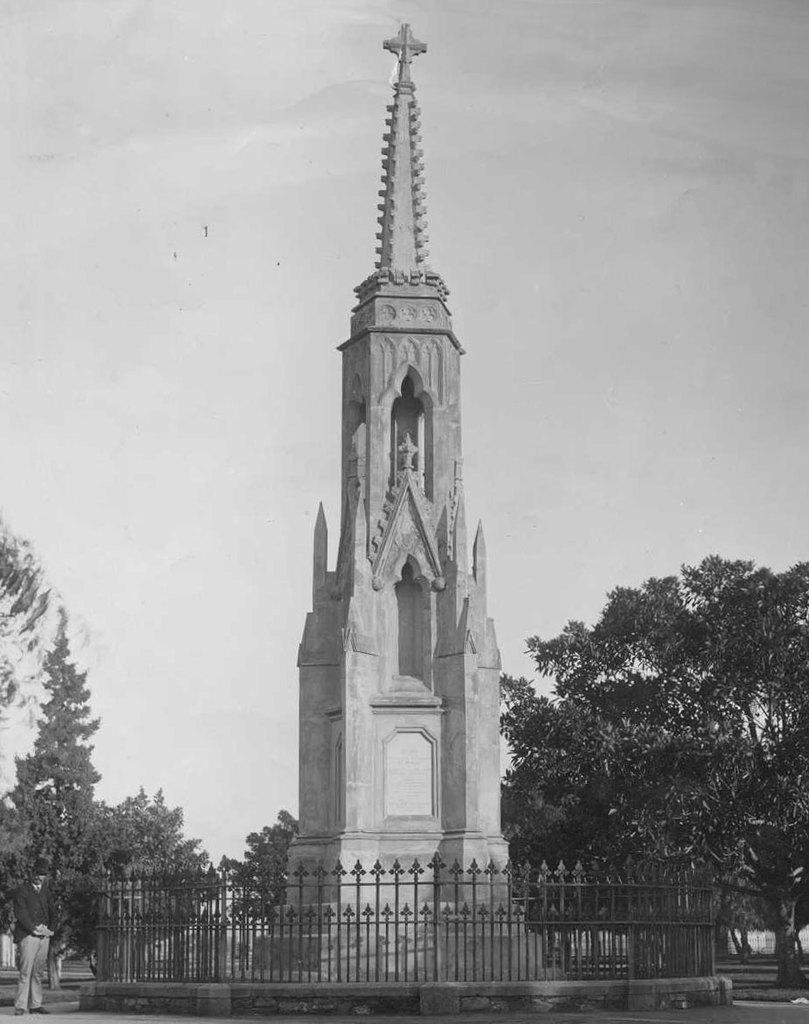What is the main structure in the image? There is a tower present in the image. What surrounds the tower? There is a metal fence around the tower. What type of vegetation can be seen in the image? There are trees in the image. Can you describe the person in the image? A man is standing in the image, and he is wearing a cap. How would you describe the weather in the image? The sky is cloudy in the image. What type of engine can be seen powering the snails in the image? There are no snails or engines present in the image. What card game is being played in the image? There is no card game or cards visible in the image. 